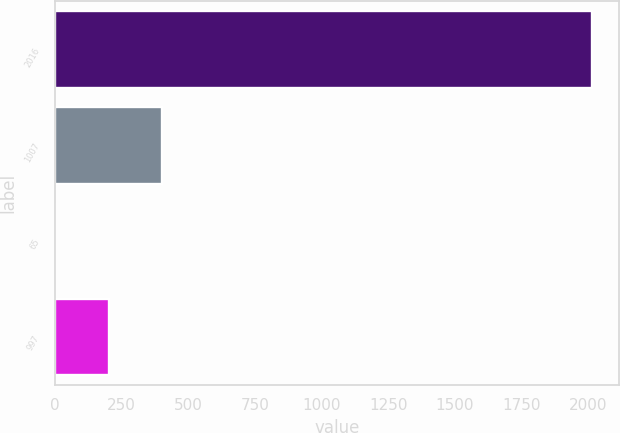Convert chart. <chart><loc_0><loc_0><loc_500><loc_500><bar_chart><fcel>2016<fcel>1007<fcel>65<fcel>997<nl><fcel>2015<fcel>403.32<fcel>0.4<fcel>201.86<nl></chart> 